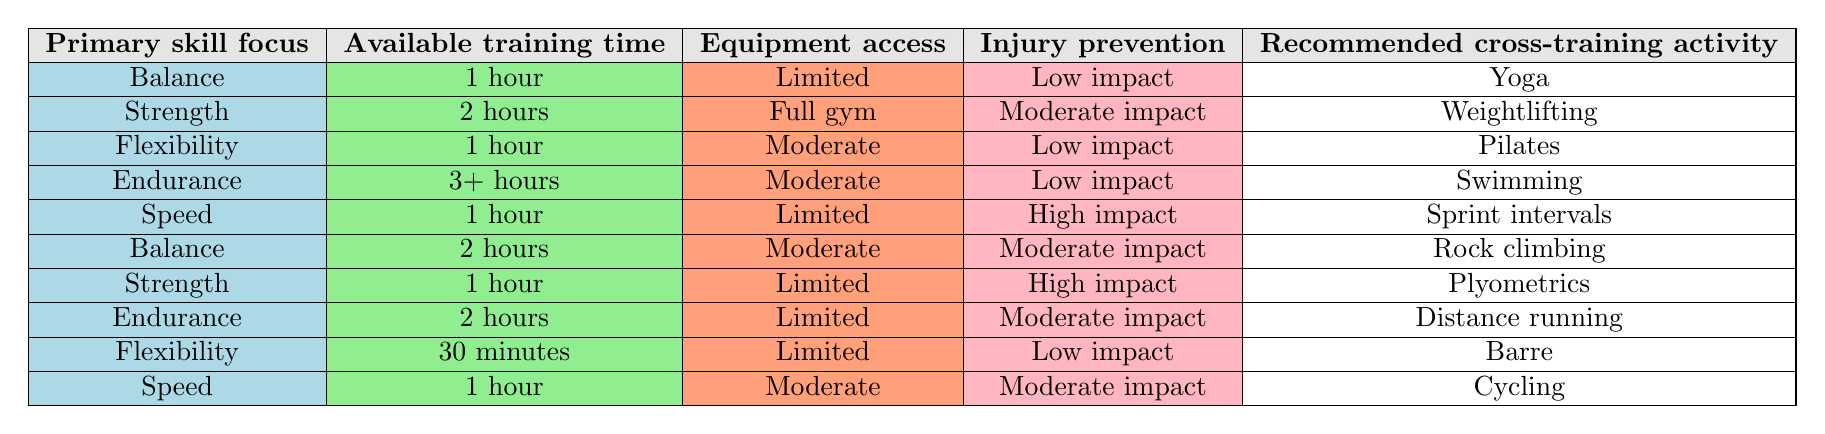What is the recommended cross-training activity for strength with 2 hours available training time and full gym access? The table lists the conditions for strength, 2 hours of available training time, and full gym access. The corresponding recommended activity is weightlifting.
Answer: Weightlifting Which cross-training activity is suggested for balance if the available training time is 1 hour and the injury prevention needs are low impact? We look for the row in the table that mentions balance, 1 hour of training time, and low impact for injury prevention. The activity listed in that row is yoga.
Answer: Yoga Is swimming recommended for endurance with 2 hours of available training time? The table shows that swimming is suggested for endurance with 3+ hours of available training time. Since 2 hours does not meet this criterion, the answer is no.
Answer: No What is the impact level of the recommended activity for speed with moderate equipment access? The speed row with moderate equipment access shows the recommended activity is cycling, which corresponds to moderate impact as listed in its conditions.
Answer: Moderate impact How many cross-training activities are suggested for a focus on flexibility? Adding the rows that highlight flexibility shows two corresponding activities in the table: Pilates and barre. Counting these, we find there are two activities suggested for flexibility.
Answer: 2 If a gymnast has 2 hours, limited equipment access, and moderate impact injury prevention needs, what is the recommended activity? There is no row in the table that fits the conditions of 2 hours, limited equipment access, and moderate impact for injury prevention. Therefore, we conclude there is no recommendation available under these conditions.
Answer: None What are the conditions that lead to the recommendation of plyometrics? The row for plyometrics shows the following conditions: primary skill focus on strength, available training time of 1 hour, equipment access is limited, with high impact for injury prevention.
Answer: Strength, 1 hour, Limited, High impact Is it true that flexibility training can be done in 30 minutes with low impact injury prevention? The table indicates that for flexibility, if there is 30 minutes of available time and low impact injury prevention, barre is the recommended activity, hence the statement is true.
Answer: Yes Which activity is recommended for endurance if 3+ hours are available and minimum equipment access is required? The endurance activity recommended for 3+ hours is swimming, and there's no mention of minimum equipment; it is assigned moderate which means access is not limited. So, swimming is still valid under these conditions.
Answer: Swimming 